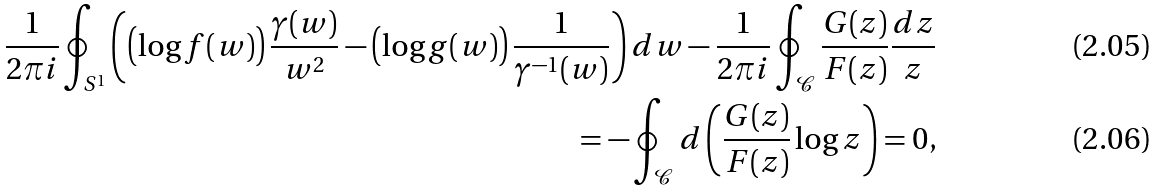Convert formula to latex. <formula><loc_0><loc_0><loc_500><loc_500>\frac { 1 } { 2 \pi i } \oint _ { S ^ { 1 } } \left ( \left ( \log f ( w ) \right ) \frac { \gamma ( w ) } { w ^ { 2 } } - \left ( \log g ( w ) \right ) \frac { 1 } { \gamma ^ { - 1 } ( w ) } \right ) d w - \frac { 1 } { 2 \pi i } \oint _ { \mathcal { C } } \frac { G ( z ) } { F ( z ) } \frac { d z } { z } \\ = - \oint _ { \mathcal { C } } d \left ( \frac { G ( z ) } { F ( z ) } \log z \right ) = 0 ,</formula> 